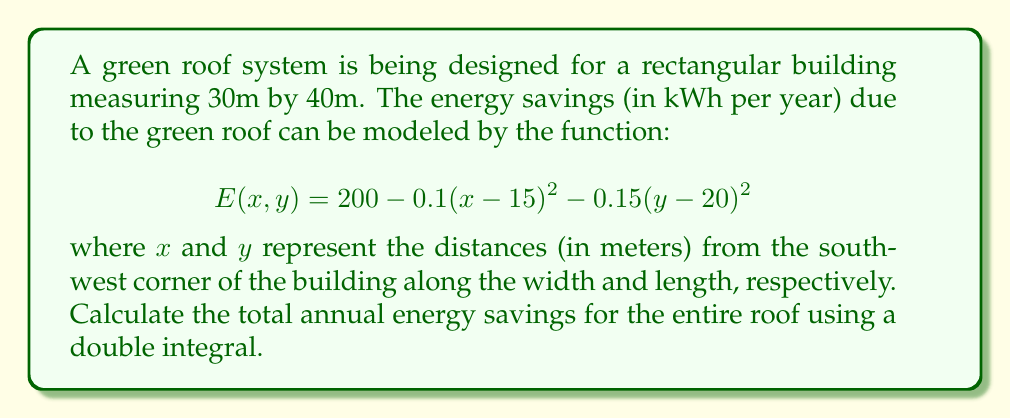Help me with this question. To solve this problem, we need to set up and evaluate a double integral over the entire roof area. Here's a step-by-step approach:

1) The integral limits are determined by the building dimensions:
   $x$ ranges from 0 to 30 (width)
   $y$ ranges from 0 to 40 (length)

2) Set up the double integral:

   $$\iint_A E(x,y) \, dA = \int_0^{40} \int_0^{30} [200 - 0.1(x-15)^2 - 0.15(y-20)^2] \, dx \, dy$$

3) Evaluate the inner integral with respect to $x$:

   $$\int_0^{40} \left[ 200x - 0.1\left(\frac{x^3}{3} - 15x^2 + 225x\right) - 0.15(y-20)^2x \right]_0^{30} \, dy$$

4) After evaluating at the limits, simplify:

   $$\int_0^{40} \left[6000 - 300 - 0.15(y-20)^2(30)\right] \, dy$$

5) Simplify further:

   $$\int_0^{40} \left[5700 - 4.5(y-20)^2\right] \, dy$$

6) Evaluate this integral:

   $$\left[5700y - 4.5\left(\frac{y^3}{3} - 40y^2 + 400y\right)\right]_0^{40}$$

7) Evaluate at the limits and simplify:

   $$228000 - 1800 - 0 = 226200$$

Thus, the total annual energy savings for the entire roof is 226,200 kWh.
Answer: 226,200 kWh per year 